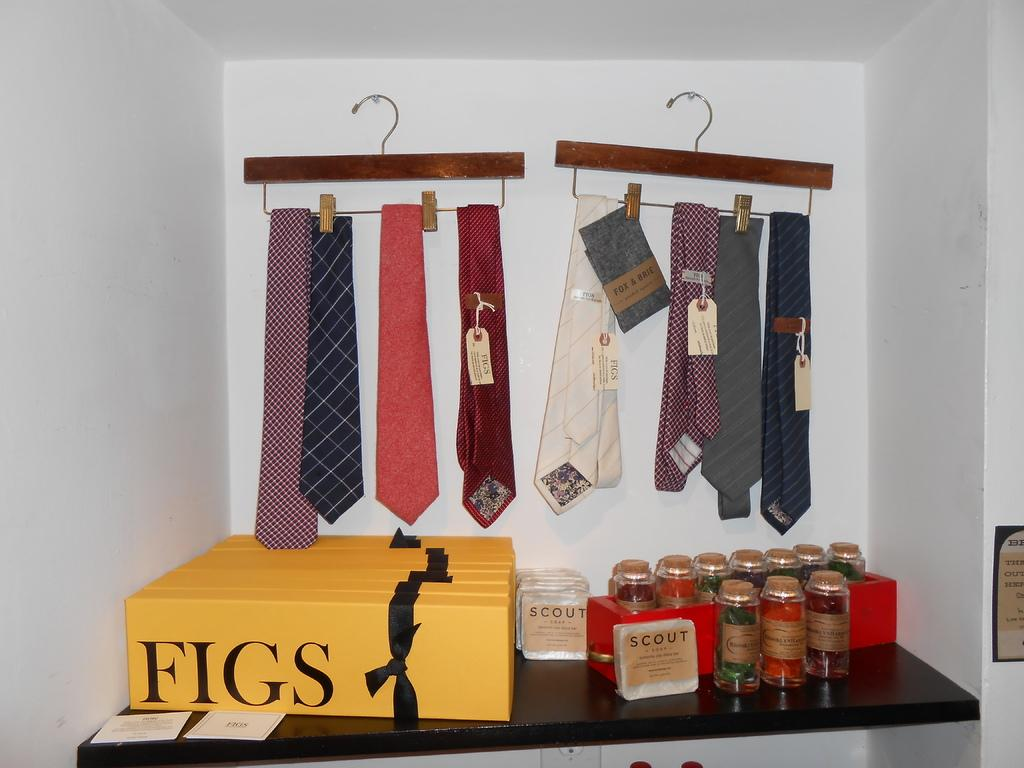What objects are on the table in the image? There are boxes, jars, packs, and cards on the table in the image. Can you describe the jars in the image? The jars are in a red color box on the table. What else is on the table besides the jars? There are packs and cards on the table. What is hanging on the white wall in the image? There are ties hanged on hangers attached to the white wall. What is the profit margin of the plane in the image? There is no plane present in the image, so it is not possible to determine the profit margin. 